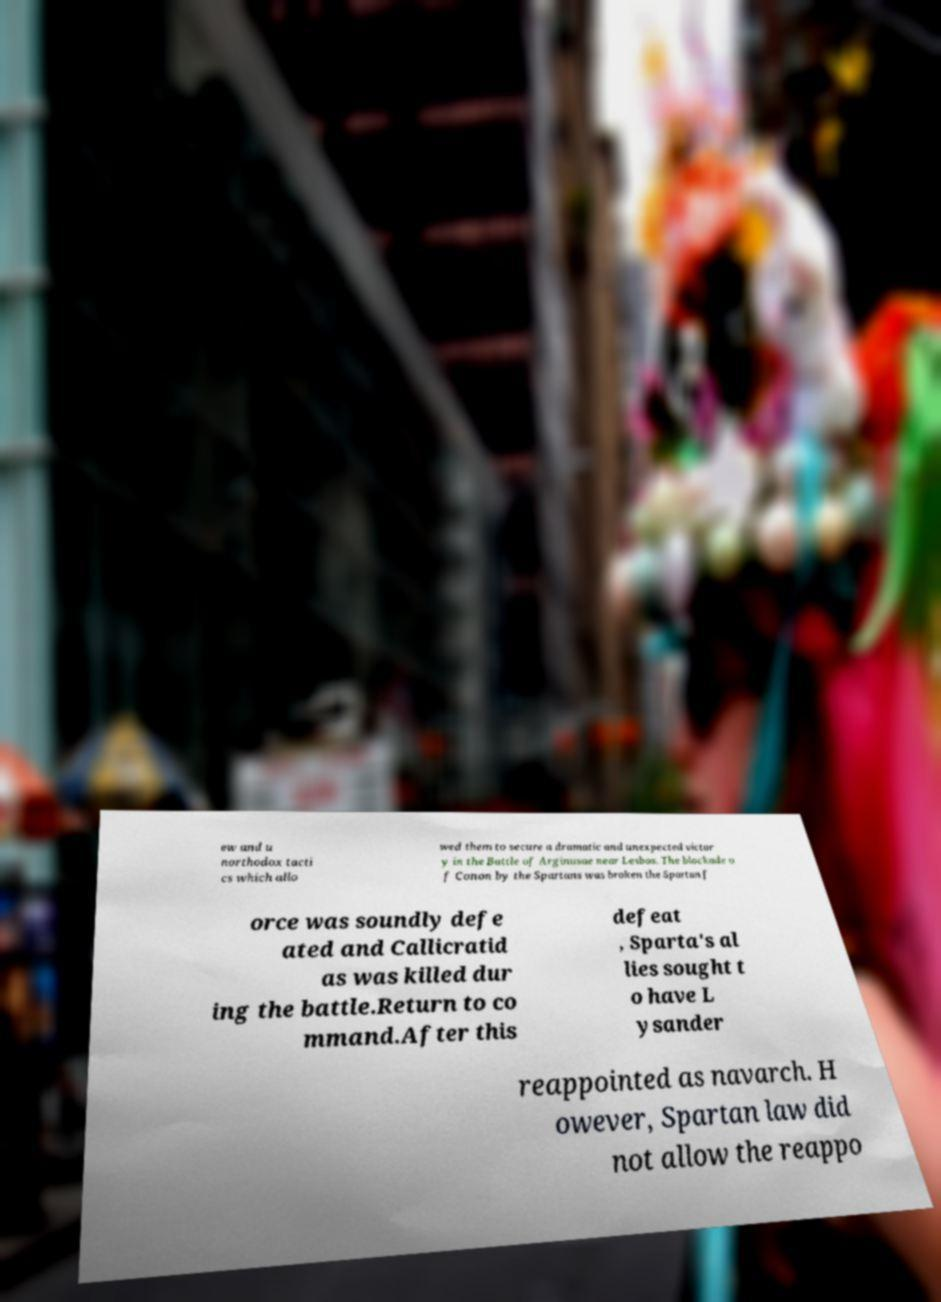Could you extract and type out the text from this image? ew and u northodox tacti cs which allo wed them to secure a dramatic and unexpected victor y in the Battle of Arginusae near Lesbos. The blockade o f Conon by the Spartans was broken the Spartan f orce was soundly defe ated and Callicratid as was killed dur ing the battle.Return to co mmand.After this defeat , Sparta's al lies sought t o have L ysander reappointed as navarch. H owever, Spartan law did not allow the reappo 